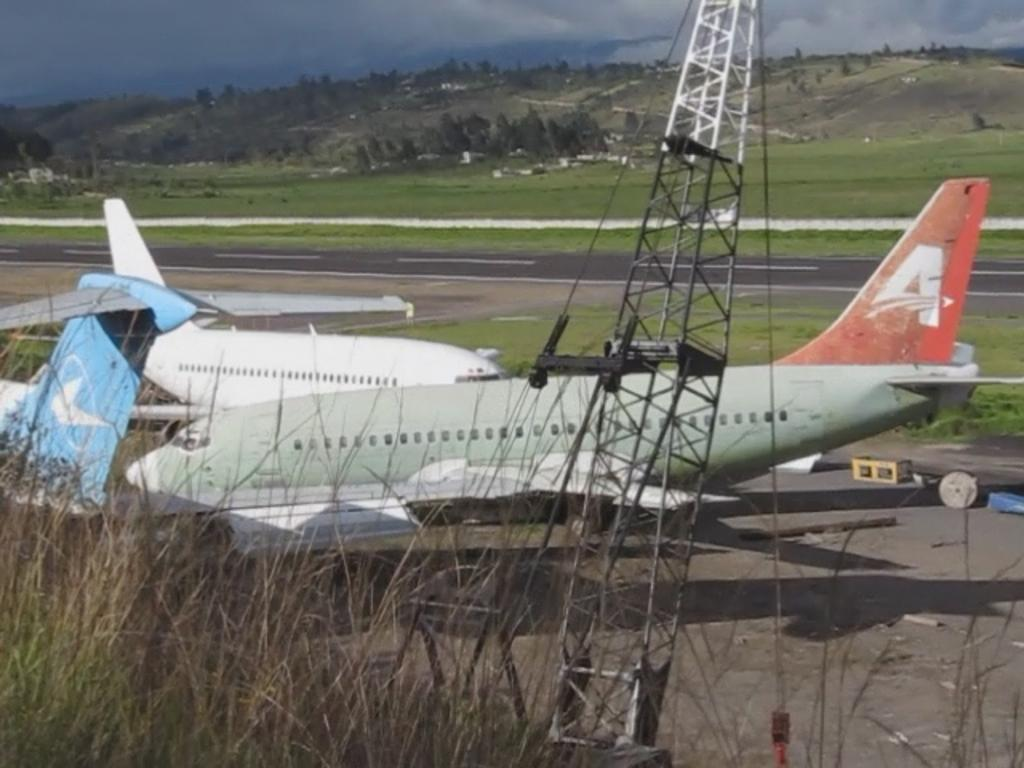Provide a one-sentence caption for the provided image. many planes are sitting at the airport, one with an A on its tail. 